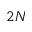<formula> <loc_0><loc_0><loc_500><loc_500>2 N</formula> 